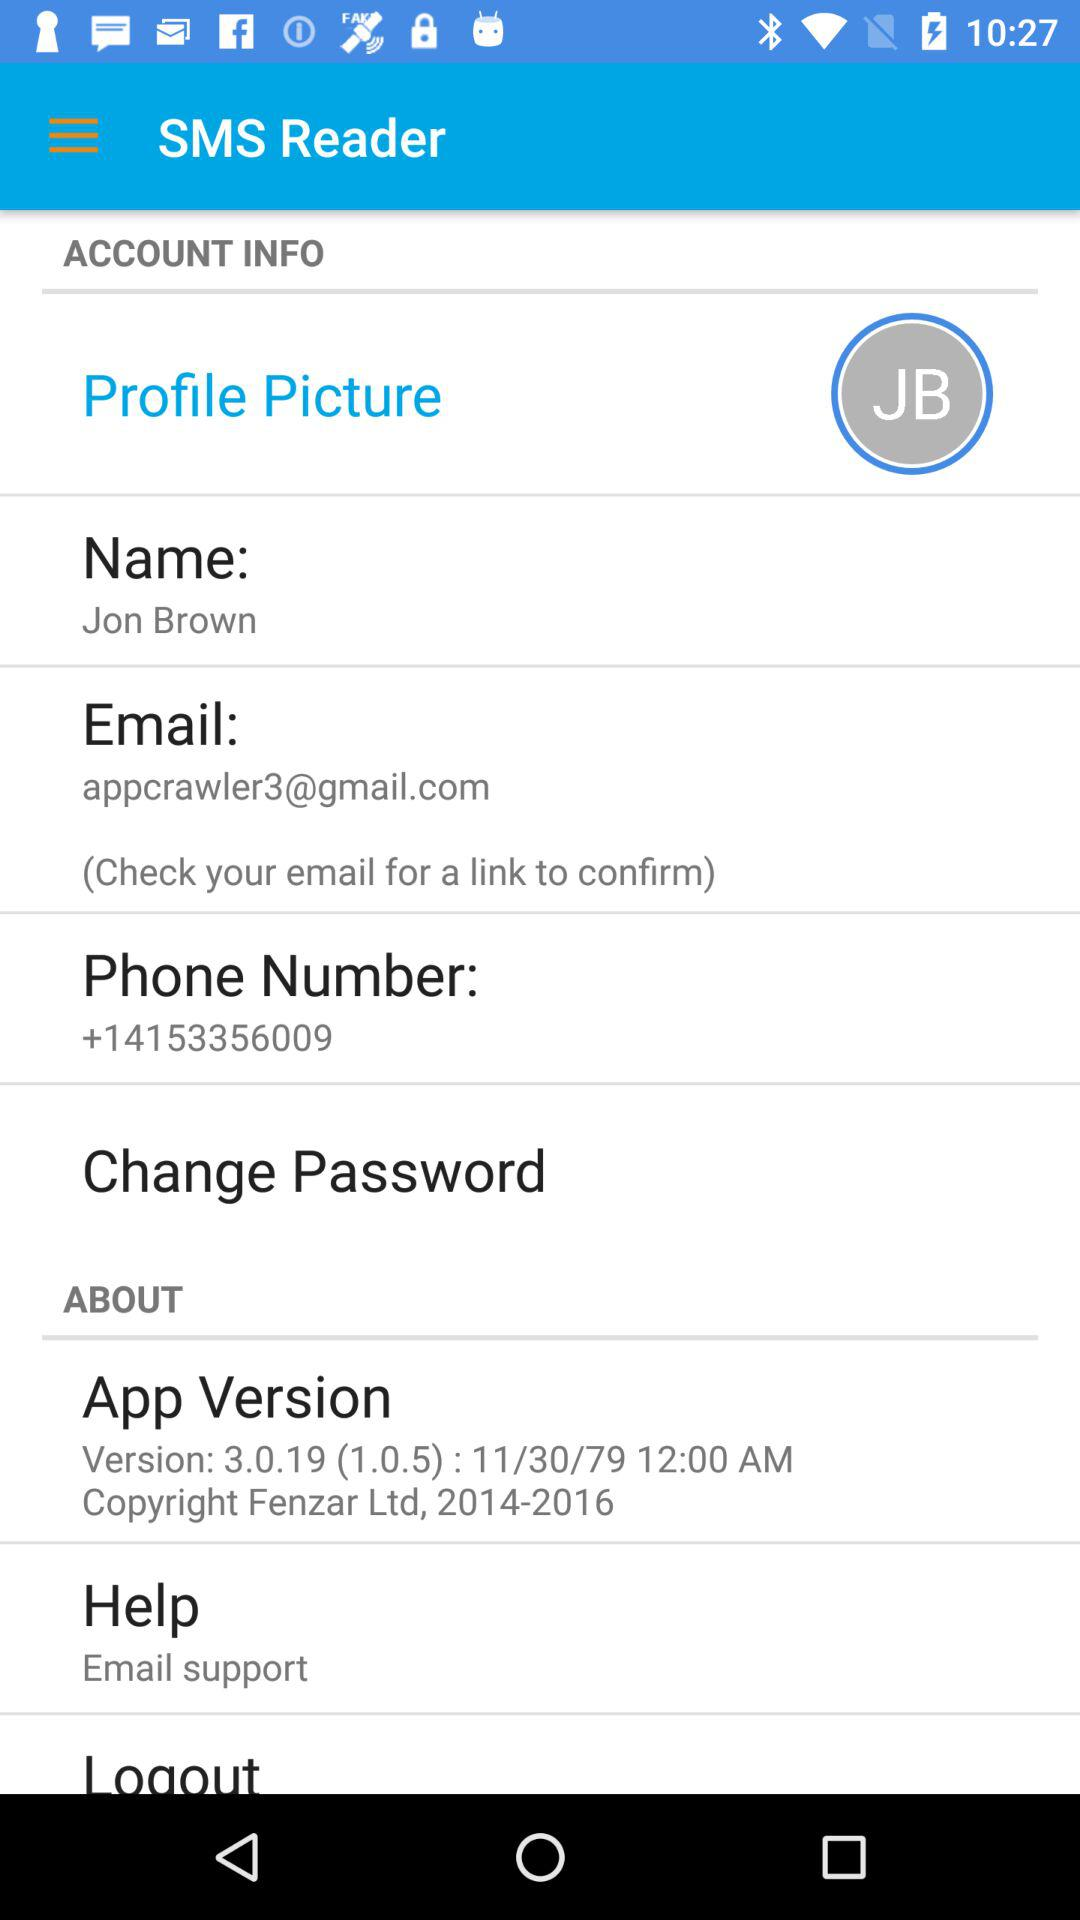How many items in the 'About' section have a version number?
Answer the question using a single word or phrase. 1 